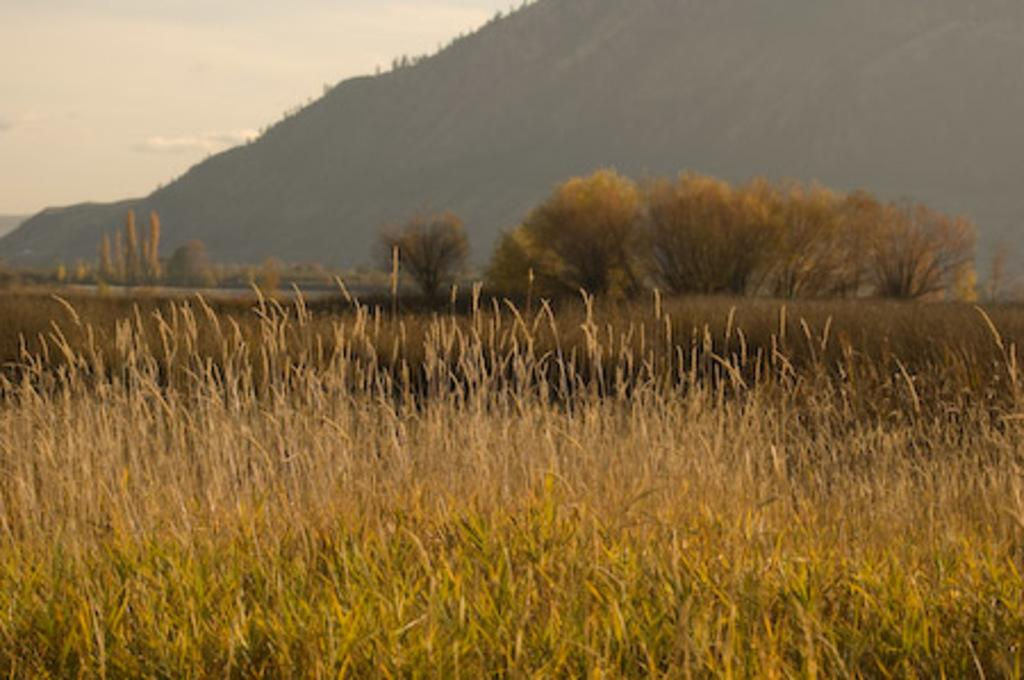What type of vegetation can be seen in the image? There are plants, grass, and trees in the image. What is the terrain like in the image? There is a mountain visible in the background of the image. What is the condition of the sky in the image? The sky is visible in the image and appears cloudy. How many beggars can be seen in the image? There are no beggars present in the image. What type of work is being done on the mountain in the image? There is no work being done on the mountain in the image; it is a natural landscape. 